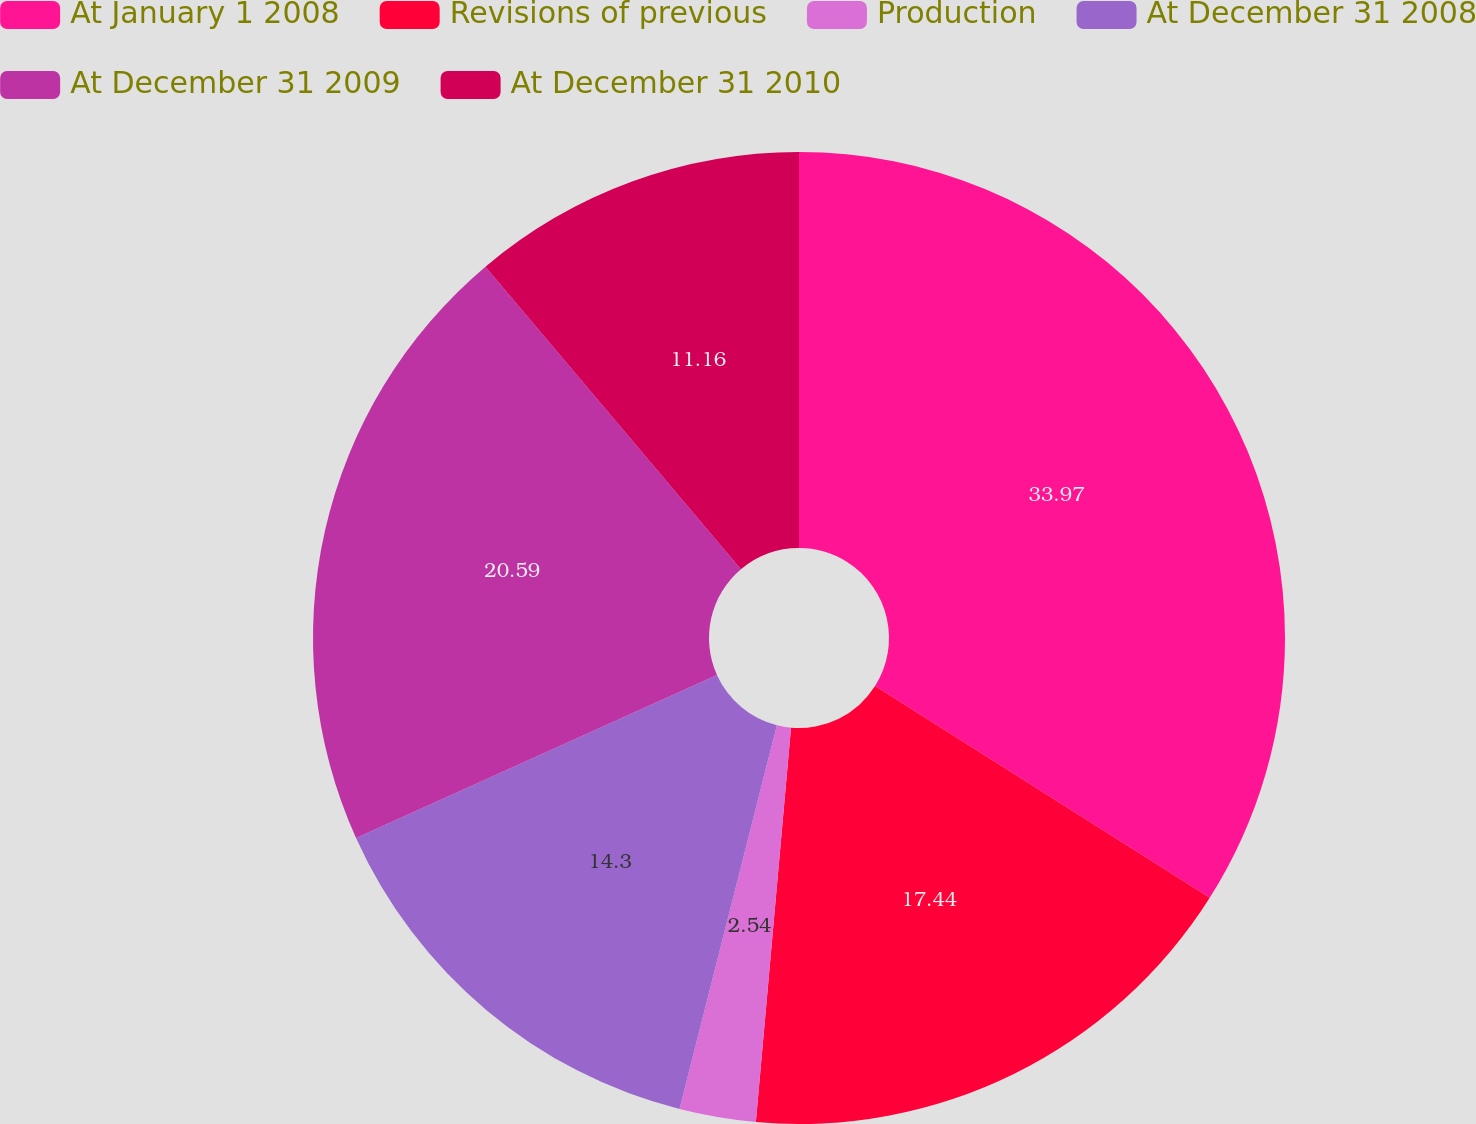<chart> <loc_0><loc_0><loc_500><loc_500><pie_chart><fcel>At January 1 2008<fcel>Revisions of previous<fcel>Production<fcel>At December 31 2008<fcel>At December 31 2009<fcel>At December 31 2010<nl><fcel>33.98%<fcel>17.44%<fcel>2.54%<fcel>14.3%<fcel>20.59%<fcel>11.16%<nl></chart> 